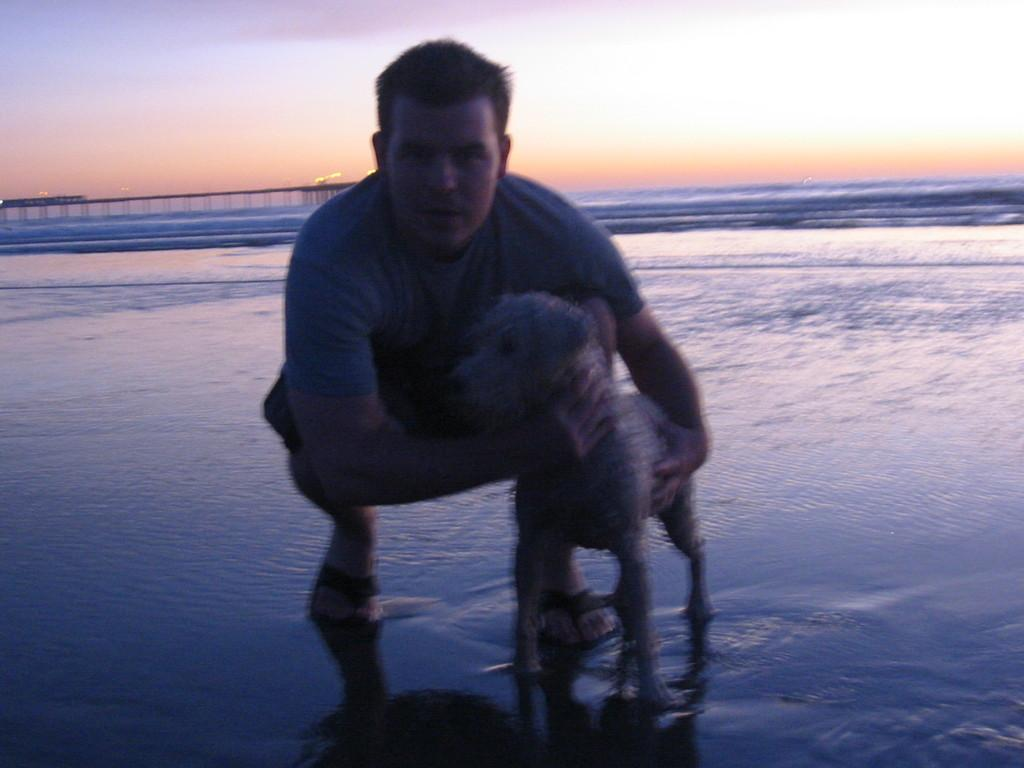Who is present in the image? There is a person in the image. What is the person doing in the image? The person is holding a dog and posing for the camera. Where is the dog located in relation to the person? The dog is beside the person. What can be seen in the background of the image? There is a bridge in the background of the image, and it is over water. How many fish can be seen swimming in the water under the bridge? There is no mention of fish in the image, so it is not possible to determine how many fish are swimming in the water under the bridge. 